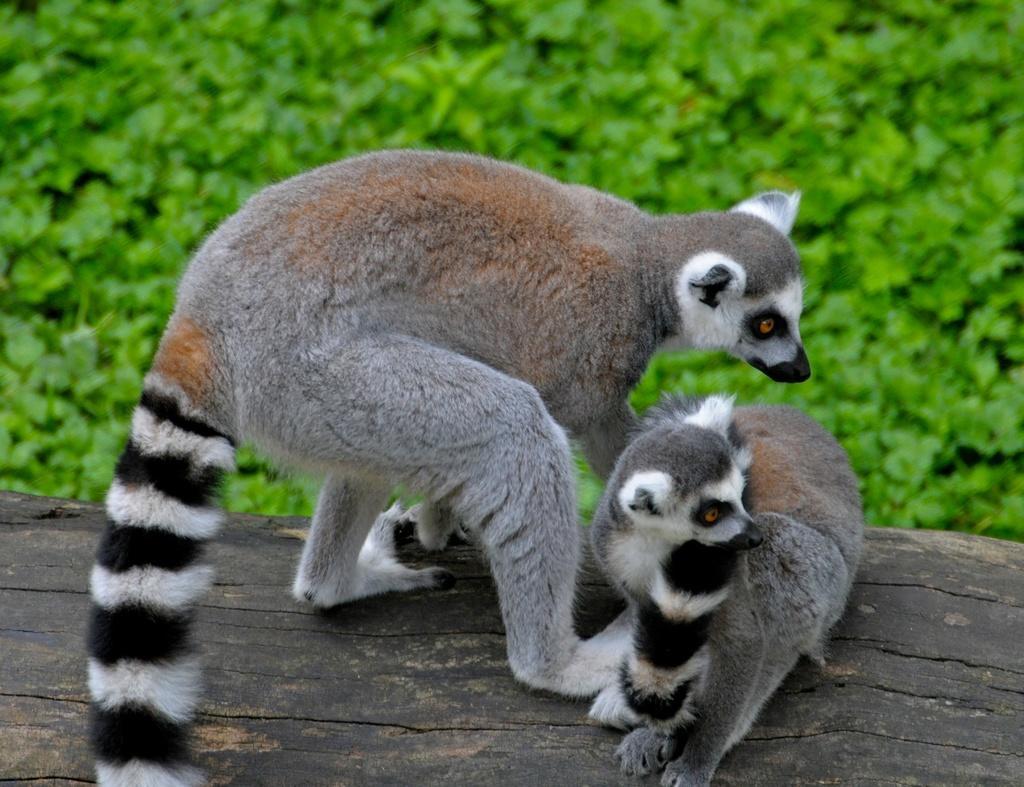How would you summarize this image in a sentence or two? In the center of the image we can see animals on the wooden block. In the background there are plants. 